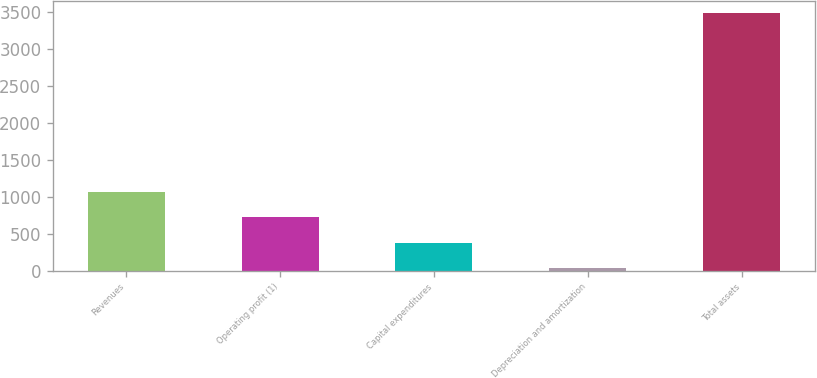Convert chart to OTSL. <chart><loc_0><loc_0><loc_500><loc_500><bar_chart><fcel>Revenues<fcel>Operating profit (1)<fcel>Capital expenditures<fcel>Depreciation and amortization<fcel>Total assets<nl><fcel>1065.4<fcel>720.6<fcel>375.8<fcel>31<fcel>3479<nl></chart> 